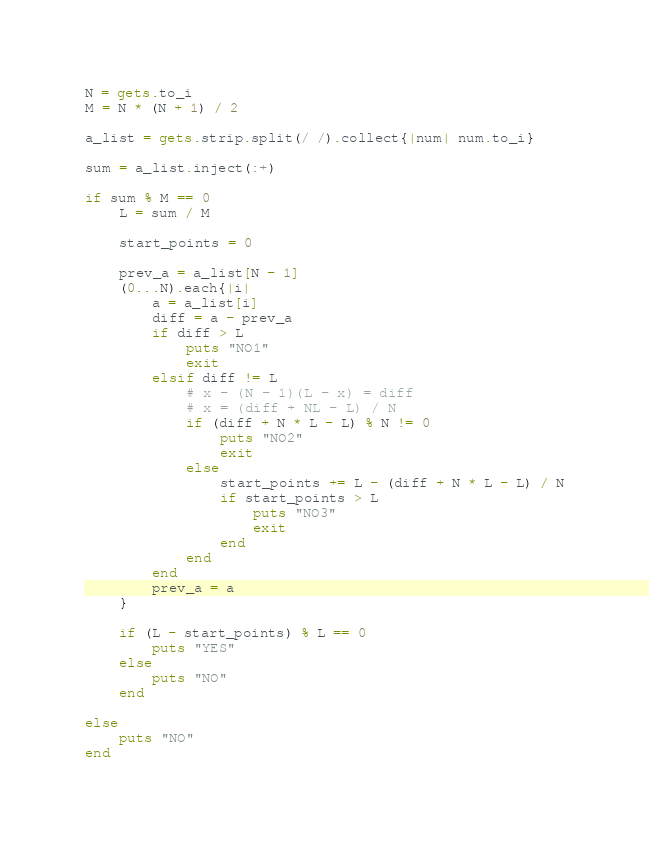Convert code to text. <code><loc_0><loc_0><loc_500><loc_500><_Ruby_>N = gets.to_i
M = N * (N + 1) / 2

a_list = gets.strip.split(/ /).collect{|num| num.to_i}

sum = a_list.inject(:+)

if sum % M == 0
	L = sum / M
	
	start_points = 0
	
	prev_a = a_list[N - 1]
	(0...N).each{|i|
		a = a_list[i]
		diff = a - prev_a
		if diff > L
			puts "NO1"
			exit
		elsif diff != L
			# x - (N - 1)(L - x) = diff
			# x = (diff + NL - L) / N
			if (diff + N * L - L) % N != 0
				puts "NO2"
				exit
			else
				start_points += L - (diff + N * L - L) / N
				if start_points > L
					puts "NO3"
					exit
				end
			end
		end
		prev_a = a
	}

	if (L - start_points) % L == 0
		puts "YES"
	else
		puts "NO"
	end
	
else
	puts "NO"
end
</code> 